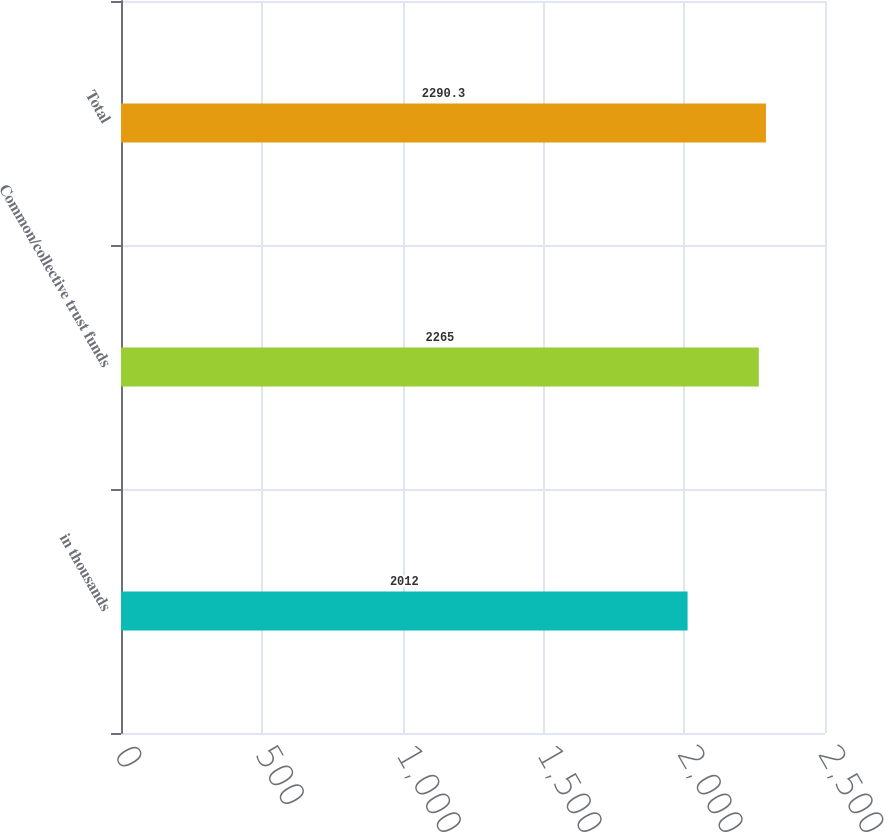Convert chart. <chart><loc_0><loc_0><loc_500><loc_500><bar_chart><fcel>in thousands<fcel>Common/collective trust funds<fcel>Total<nl><fcel>2012<fcel>2265<fcel>2290.3<nl></chart> 